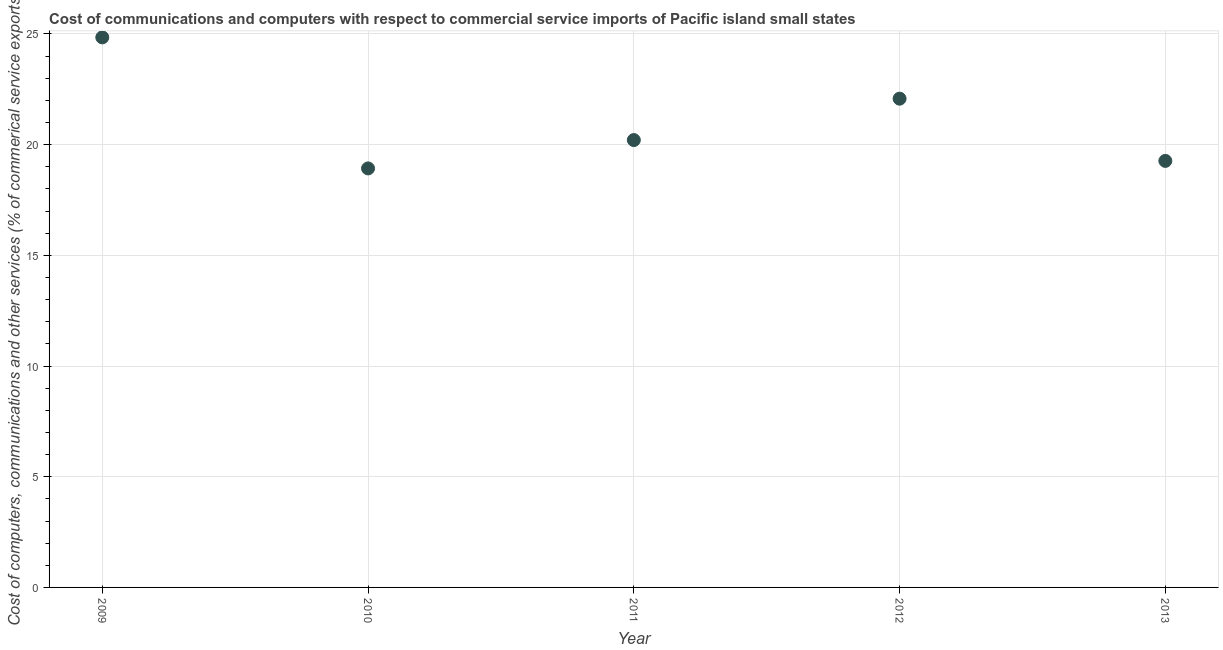What is the  computer and other services in 2012?
Make the answer very short. 22.08. Across all years, what is the maximum  computer and other services?
Give a very brief answer. 24.85. Across all years, what is the minimum  computer and other services?
Provide a short and direct response. 18.93. In which year was the  computer and other services minimum?
Provide a succinct answer. 2010. What is the sum of the cost of communications?
Provide a succinct answer. 105.33. What is the difference between the  computer and other services in 2011 and 2012?
Your answer should be compact. -1.87. What is the average cost of communications per year?
Your answer should be very brief. 21.07. What is the median cost of communications?
Provide a succinct answer. 20.21. In how many years, is the  computer and other services greater than 12 %?
Keep it short and to the point. 5. What is the ratio of the cost of communications in 2009 to that in 2011?
Give a very brief answer. 1.23. Is the difference between the cost of communications in 2011 and 2013 greater than the difference between any two years?
Provide a short and direct response. No. What is the difference between the highest and the second highest  computer and other services?
Your answer should be very brief. 2.77. What is the difference between the highest and the lowest cost of communications?
Give a very brief answer. 5.92. In how many years, is the cost of communications greater than the average cost of communications taken over all years?
Give a very brief answer. 2. How many dotlines are there?
Offer a very short reply. 1. What is the difference between two consecutive major ticks on the Y-axis?
Your response must be concise. 5. Are the values on the major ticks of Y-axis written in scientific E-notation?
Provide a short and direct response. No. Does the graph contain grids?
Offer a very short reply. Yes. What is the title of the graph?
Your answer should be compact. Cost of communications and computers with respect to commercial service imports of Pacific island small states. What is the label or title of the Y-axis?
Keep it short and to the point. Cost of computers, communications and other services (% of commerical service exports). What is the Cost of computers, communications and other services (% of commerical service exports) in 2009?
Offer a very short reply. 24.85. What is the Cost of computers, communications and other services (% of commerical service exports) in 2010?
Offer a very short reply. 18.93. What is the Cost of computers, communications and other services (% of commerical service exports) in 2011?
Make the answer very short. 20.21. What is the Cost of computers, communications and other services (% of commerical service exports) in 2012?
Offer a terse response. 22.08. What is the Cost of computers, communications and other services (% of commerical service exports) in 2013?
Offer a very short reply. 19.27. What is the difference between the Cost of computers, communications and other services (% of commerical service exports) in 2009 and 2010?
Provide a succinct answer. 5.92. What is the difference between the Cost of computers, communications and other services (% of commerical service exports) in 2009 and 2011?
Provide a succinct answer. 4.64. What is the difference between the Cost of computers, communications and other services (% of commerical service exports) in 2009 and 2012?
Provide a succinct answer. 2.77. What is the difference between the Cost of computers, communications and other services (% of commerical service exports) in 2009 and 2013?
Offer a terse response. 5.58. What is the difference between the Cost of computers, communications and other services (% of commerical service exports) in 2010 and 2011?
Your answer should be compact. -1.28. What is the difference between the Cost of computers, communications and other services (% of commerical service exports) in 2010 and 2012?
Keep it short and to the point. -3.15. What is the difference between the Cost of computers, communications and other services (% of commerical service exports) in 2010 and 2013?
Your answer should be compact. -0.34. What is the difference between the Cost of computers, communications and other services (% of commerical service exports) in 2011 and 2012?
Offer a terse response. -1.87. What is the difference between the Cost of computers, communications and other services (% of commerical service exports) in 2012 and 2013?
Your answer should be compact. 2.81. What is the ratio of the Cost of computers, communications and other services (% of commerical service exports) in 2009 to that in 2010?
Your answer should be very brief. 1.31. What is the ratio of the Cost of computers, communications and other services (% of commerical service exports) in 2009 to that in 2011?
Provide a short and direct response. 1.23. What is the ratio of the Cost of computers, communications and other services (% of commerical service exports) in 2009 to that in 2012?
Offer a terse response. 1.12. What is the ratio of the Cost of computers, communications and other services (% of commerical service exports) in 2009 to that in 2013?
Make the answer very short. 1.29. What is the ratio of the Cost of computers, communications and other services (% of commerical service exports) in 2010 to that in 2011?
Offer a terse response. 0.94. What is the ratio of the Cost of computers, communications and other services (% of commerical service exports) in 2010 to that in 2012?
Your answer should be compact. 0.86. What is the ratio of the Cost of computers, communications and other services (% of commerical service exports) in 2010 to that in 2013?
Offer a very short reply. 0.98. What is the ratio of the Cost of computers, communications and other services (% of commerical service exports) in 2011 to that in 2012?
Provide a short and direct response. 0.92. What is the ratio of the Cost of computers, communications and other services (% of commerical service exports) in 2011 to that in 2013?
Provide a short and direct response. 1.05. What is the ratio of the Cost of computers, communications and other services (% of commerical service exports) in 2012 to that in 2013?
Your answer should be very brief. 1.15. 